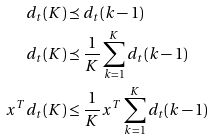<formula> <loc_0><loc_0><loc_500><loc_500>d _ { t } ( K ) & \preceq d _ { t } ( k - 1 ) \\ d _ { t } ( K ) & \preceq \frac { 1 } { K } \sum _ { k = 1 } ^ { K } d _ { t } ( k - 1 ) \\ x ^ { T } d _ { t } ( K ) & \leq \frac { 1 } { K } x ^ { T } \sum _ { k = 1 } ^ { K } d _ { t } ( k - 1 )</formula> 